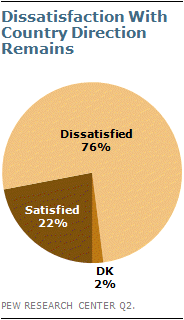List a handful of essential elements in this visual. The average of "Dissatisfied" and "Satisfied" is 0.49. 